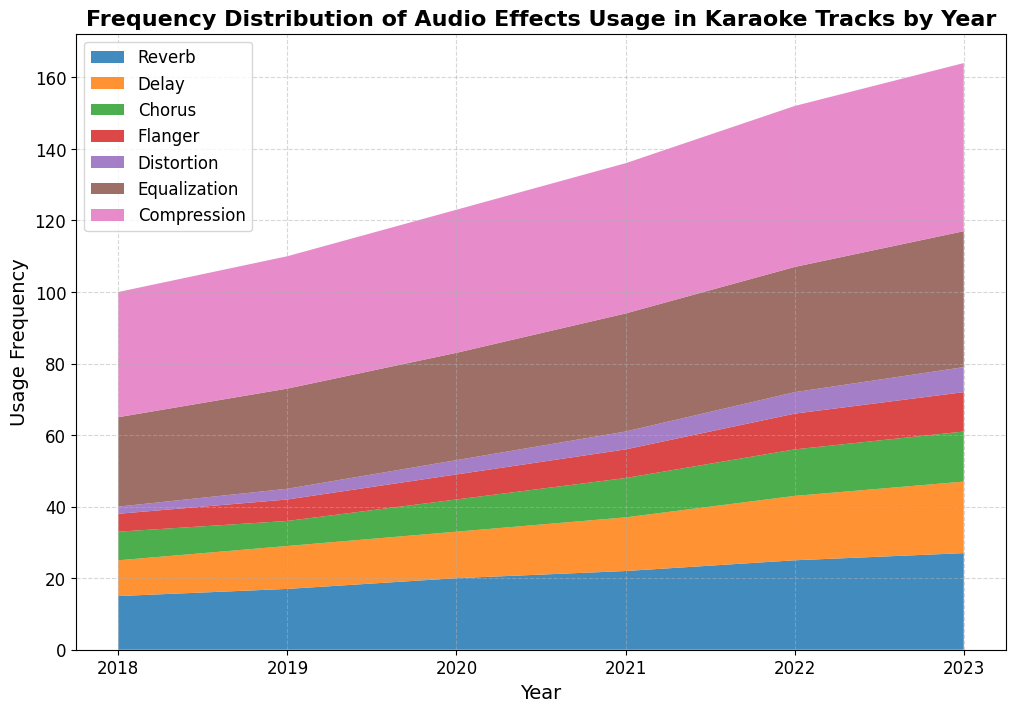What is the overall trend in the usage frequency of Reverb from 2018 to 2023? The visual representation of the area of the reverb part of the chart shows a consistent increase each year, indicating a rising trend in its usage frequency.
Answer: Increasing Which audio effect had the highest frequency of usage in 2023? By looking at the height (area) of the stacked regions in 2023, Compression is the tallest and hence the most used effect.
Answer: Compression Among Delay and Equalization, which had a larger increase in usage frequency from 2018 to 2023? Delay increased from 10 to 20 (a difference of 10), while Equalization increased from 25 to 38 (a difference of 13). Thus, Equalization had a larger increase.
Answer: Equalization What is the combined frequency of Chorus and Flanger usage in 2022? In 2022, Chorus is 13 and Flanger is 10. Adding these gives 13 + 10 = 23.
Answer: 23 Which year shows the greatest rise in usage frequency for Reverb compared to the previous year? Analyzing the differences year over year:  
2019-2018 = 17-15 = 2,  
2020-2019 = 20-17 = 3,  
2021-2020 = 22-20 = 2,  
2022-2021 = 25-22 = 3,  
2023-2022 = 27-25 = 2.  
The largest difference is from 2020 to 2019 (3 units).
Answer: 2020 Is there any year when the usage of Compression is less than the usage of Equalization? By observing the chart, we see that in every year from 2018 to 2023, the height of Compression is greater than that of Equalization, indicating that Compression usage never fell below Equalization.
Answer: No How does the usage of Chorus in 2023 compare to its usage in 2018? In 2023, Chorus is at 14 and in 2018 it was at 8. This shows that its usage has nearly doubled over the period.
Answer: Almost doubled In 2021, which effect had the least usage frequency? In 2021, the smallest area stack represents Distortion, which is at 5.
Answer: Distortion What is the average usage frequency of Delay from 2018 to 2023? Sum the usage frequencies (10 + 12 + 13 + 15 + 18 + 20) = 88. There are 6 entries, so the average is 88 / 6 = ~14.67.
Answer: ~14.67 